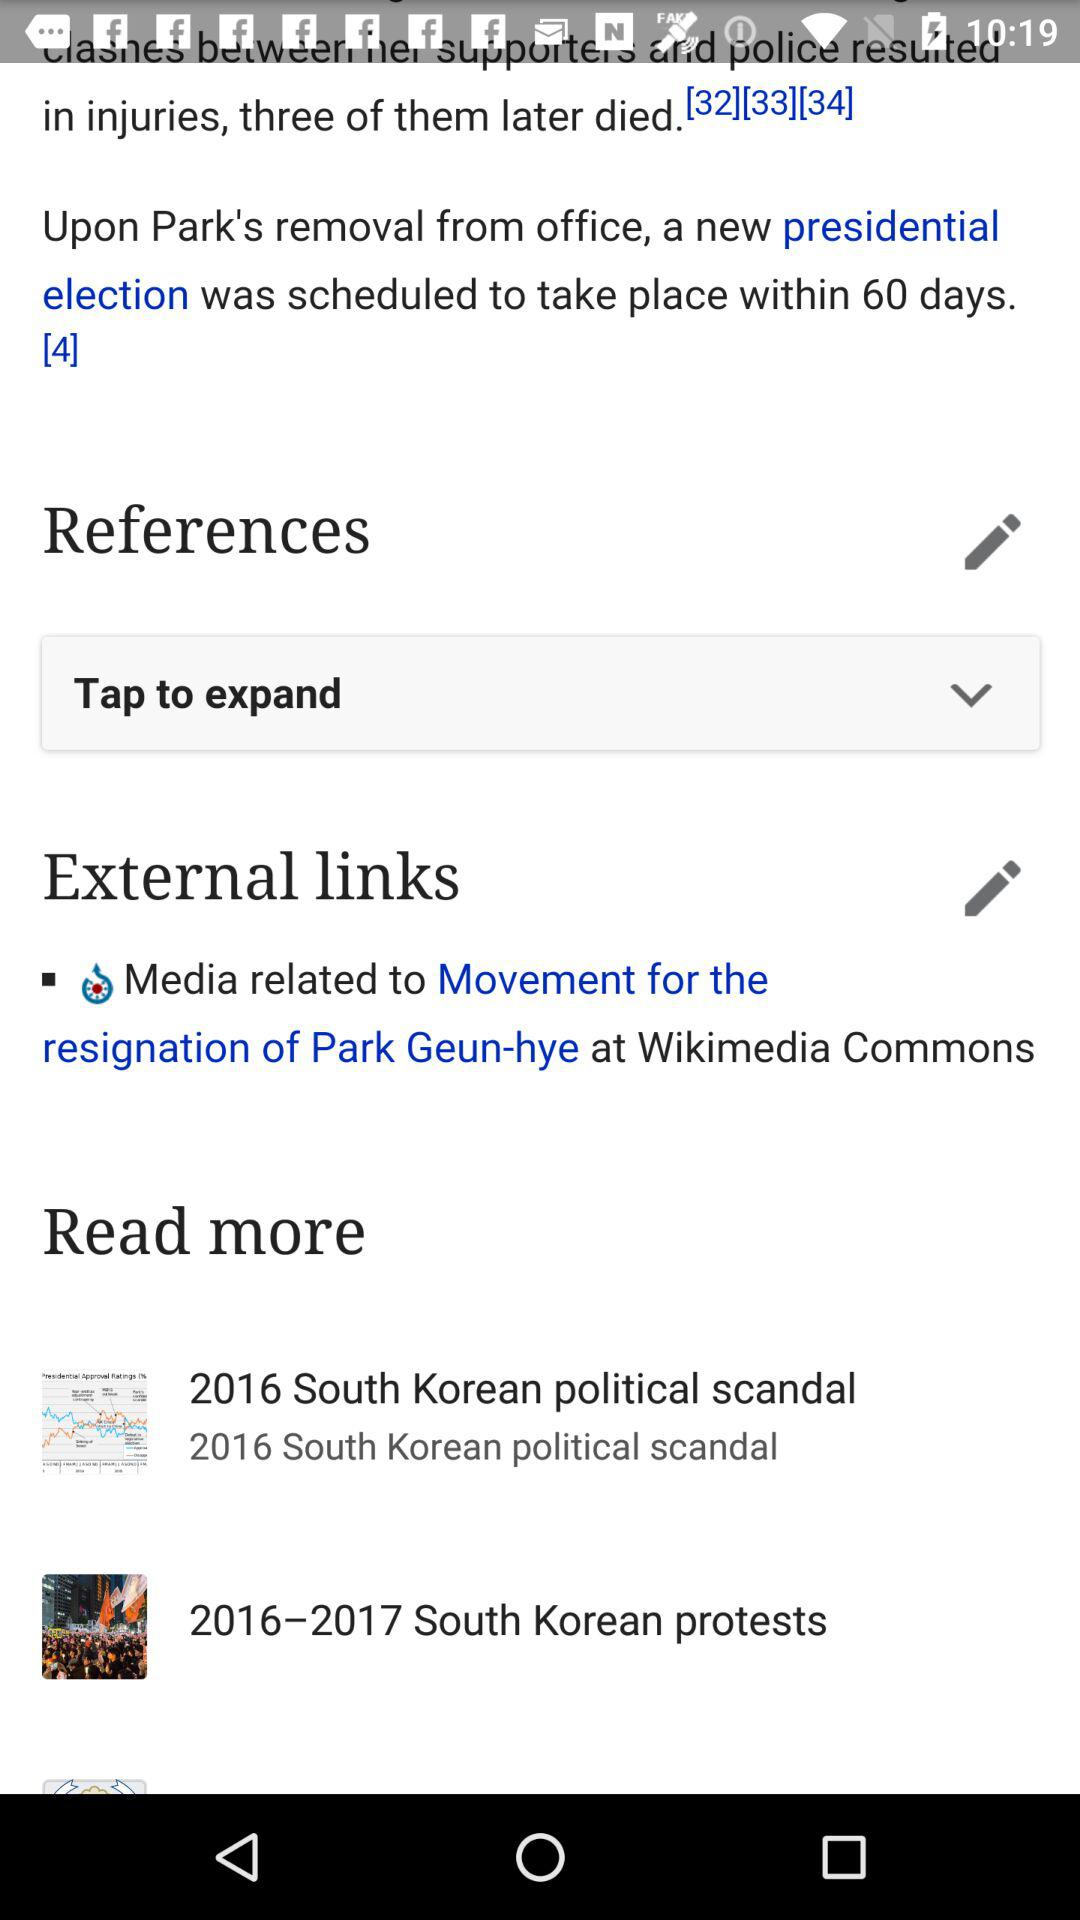In which year did the South Korean protests happen? The South Korean protests happened from 2016 to 2017. 